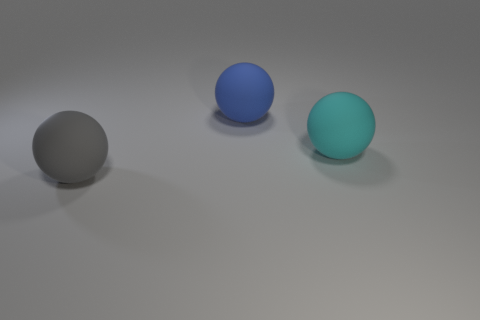Are there more small brown matte balls than big balls?
Your answer should be very brief. No. Does the object to the right of the large blue thing have the same shape as the large blue object?
Offer a terse response. Yes. How many large balls are behind the big gray object and on the left side of the big cyan rubber thing?
Keep it short and to the point. 1. How many other cyan objects are the same shape as the cyan rubber thing?
Provide a short and direct response. 0. There is a big sphere that is to the right of the ball behind the large cyan ball; what is its color?
Offer a very short reply. Cyan. There is a cyan rubber object; does it have the same shape as the large matte thing that is behind the big cyan rubber object?
Your answer should be compact. Yes. There is a ball that is on the right side of the big ball that is behind the rubber ball to the right of the big blue matte sphere; what is its material?
Keep it short and to the point. Rubber. Is there another matte object that has the same size as the blue rubber thing?
Your answer should be compact. Yes. The blue object that is made of the same material as the gray ball is what size?
Ensure brevity in your answer.  Large. The big gray object has what shape?
Provide a short and direct response. Sphere. 